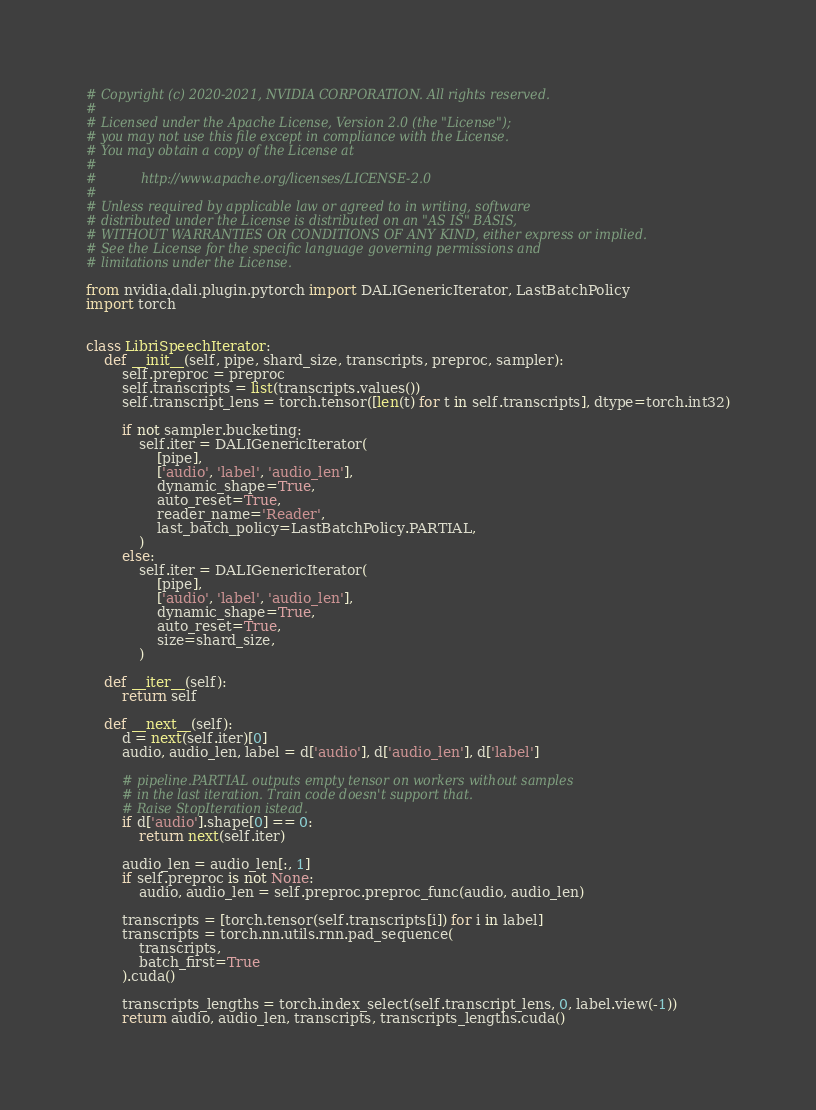<code> <loc_0><loc_0><loc_500><loc_500><_Python_># Copyright (c) 2020-2021, NVIDIA CORPORATION. All rights reserved.
#
# Licensed under the Apache License, Version 2.0 (the "License");
# you may not use this file except in compliance with the License.
# You may obtain a copy of the License at
#
#           http://www.apache.org/licenses/LICENSE-2.0
#
# Unless required by applicable law or agreed to in writing, software
# distributed under the License is distributed on an "AS IS" BASIS,
# WITHOUT WARRANTIES OR CONDITIONS OF ANY KIND, either express or implied.
# See the License for the specific language governing permissions and
# limitations under the License.

from nvidia.dali.plugin.pytorch import DALIGenericIterator, LastBatchPolicy
import torch


class LibriSpeechIterator:
    def __init__(self, pipe, shard_size, transcripts, preproc, sampler):
        self.preproc = preproc
        self.transcripts = list(transcripts.values())
        self.transcript_lens = torch.tensor([len(t) for t in self.transcripts], dtype=torch.int32)

        if not sampler.bucketing:
            self.iter = DALIGenericIterator(
                [pipe],
                ['audio', 'label', 'audio_len'],
                dynamic_shape=True,
                auto_reset=True,
                reader_name='Reader',
                last_batch_policy=LastBatchPolicy.PARTIAL,
            )
        else:
            self.iter = DALIGenericIterator(
                [pipe],
                ['audio', 'label', 'audio_len'],
                dynamic_shape=True,
                auto_reset=True,
                size=shard_size,
            )

    def __iter__(self):
        return self

    def __next__(self):
        d = next(self.iter)[0]
        audio, audio_len, label = d['audio'], d['audio_len'], d['label']

        # pipeline.PARTIAL outputs empty tensor on workers without samples
        # in the last iteration. Train code doesn't support that.
        # Raise StopIteration istead.
        if d['audio'].shape[0] == 0:
            return next(self.iter)

        audio_len = audio_len[:, 1]
        if self.preproc is not None:
            audio, audio_len = self.preproc.preproc_func(audio, audio_len)

        transcripts = [torch.tensor(self.transcripts[i]) for i in label]
        transcripts = torch.nn.utils.rnn.pad_sequence(
            transcripts,
            batch_first=True
        ).cuda()

        transcripts_lengths = torch.index_select(self.transcript_lens, 0, label.view(-1))
        return audio, audio_len, transcripts, transcripts_lengths.cuda()

</code> 